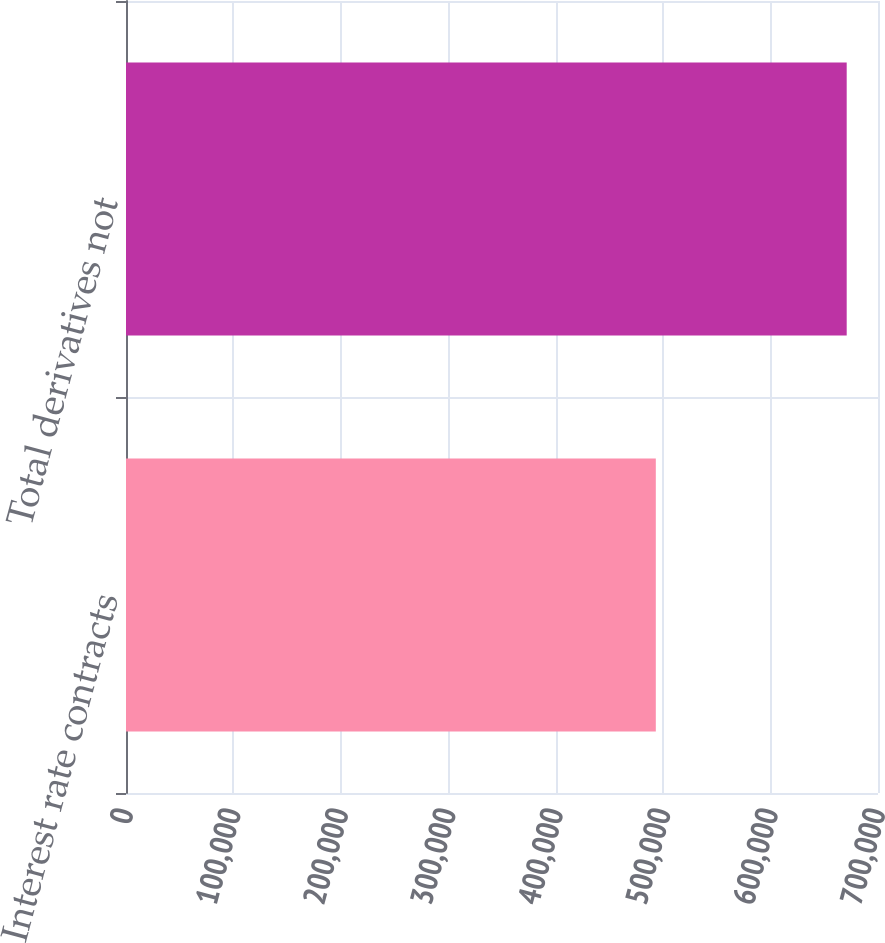Convert chart. <chart><loc_0><loc_0><loc_500><loc_500><bar_chart><fcel>Interest rate contracts<fcel>Total derivatives not<nl><fcel>493173<fcel>670867<nl></chart> 